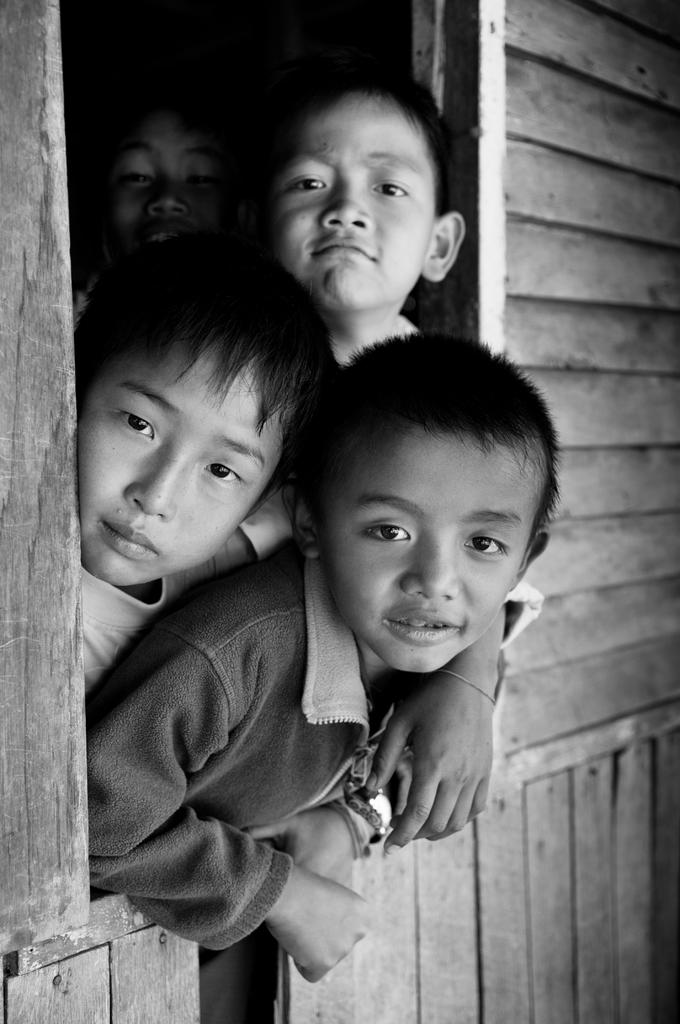What is the color scheme of the image? The image is black and white. How many boys are present in the image? There are four boys in the image. What are the boys doing in the image? The boys are peeping through a window. What type of wall is beside the window? There is a wooden wall beside the window. Can you tell me which boy is about to make a turn in the chess game? There is no chess game present in the image, as it features four boys peeping through a window with a wooden wall beside it. 